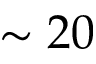<formula> <loc_0><loc_0><loc_500><loc_500>\sim 2 0</formula> 